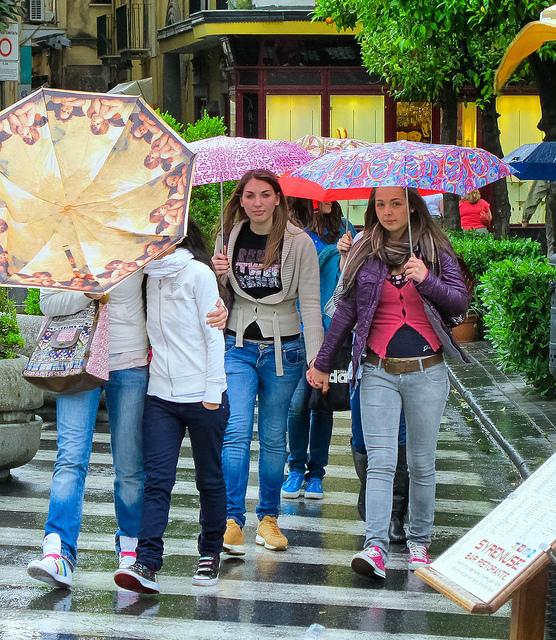How many girls?
Give a very brief answer. 5. Is everyone a female in the picture?
Concise answer only. Yes. How many women wearing converse?
Give a very brief answer. 2. What figure is on the border of the left umbrella?
Short answer required. Angels. 